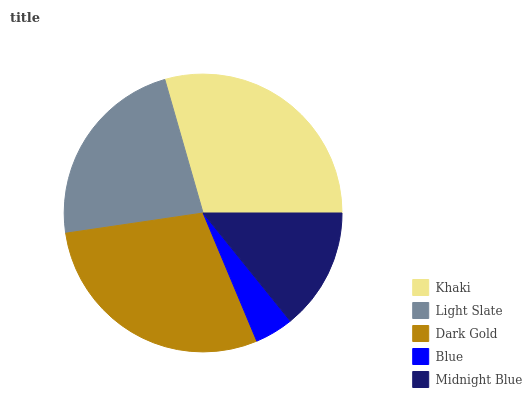Is Blue the minimum?
Answer yes or no. Yes. Is Khaki the maximum?
Answer yes or no. Yes. Is Light Slate the minimum?
Answer yes or no. No. Is Light Slate the maximum?
Answer yes or no. No. Is Khaki greater than Light Slate?
Answer yes or no. Yes. Is Light Slate less than Khaki?
Answer yes or no. Yes. Is Light Slate greater than Khaki?
Answer yes or no. No. Is Khaki less than Light Slate?
Answer yes or no. No. Is Light Slate the high median?
Answer yes or no. Yes. Is Light Slate the low median?
Answer yes or no. Yes. Is Khaki the high median?
Answer yes or no. No. Is Dark Gold the low median?
Answer yes or no. No. 